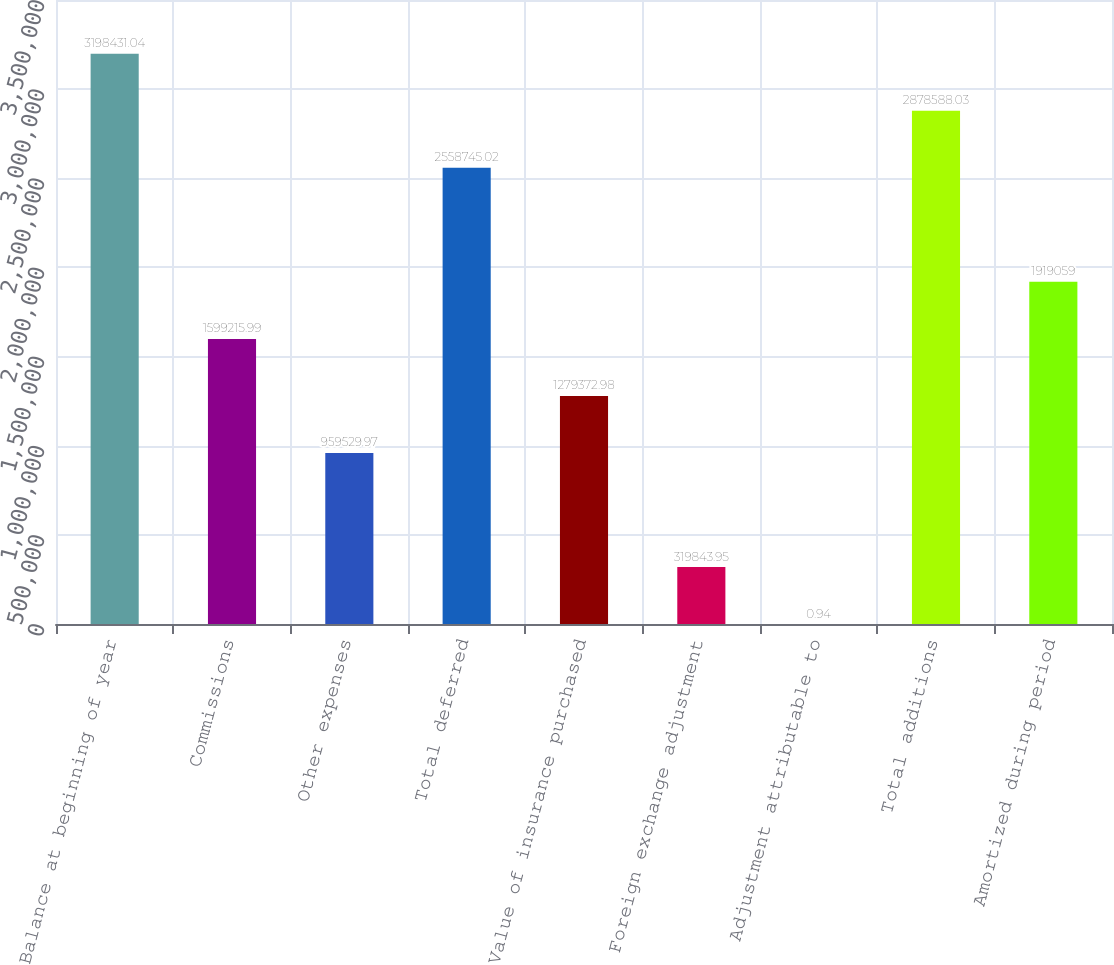Convert chart to OTSL. <chart><loc_0><loc_0><loc_500><loc_500><bar_chart><fcel>Balance at beginning of year<fcel>Commissions<fcel>Other expenses<fcel>Total deferred<fcel>Value of insurance purchased<fcel>Foreign exchange adjustment<fcel>Adjustment attributable to<fcel>Total additions<fcel>Amortized during period<nl><fcel>3.19843e+06<fcel>1.59922e+06<fcel>959530<fcel>2.55875e+06<fcel>1.27937e+06<fcel>319844<fcel>0.94<fcel>2.87859e+06<fcel>1.91906e+06<nl></chart> 